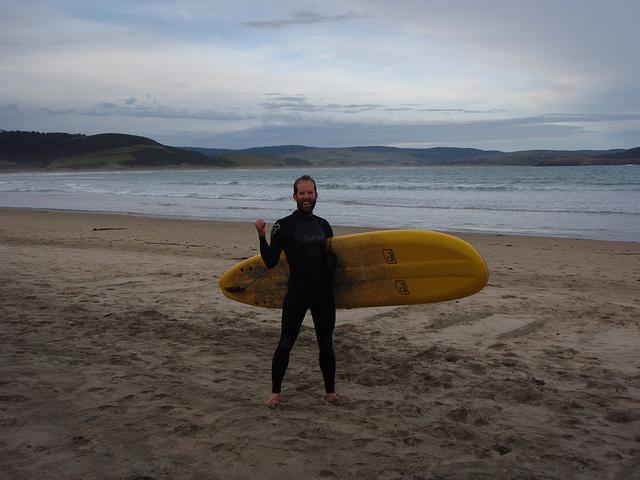How many surfboards are there?
Give a very brief answer. 1. How many cars are in front of the motorcycle?
Give a very brief answer. 0. 